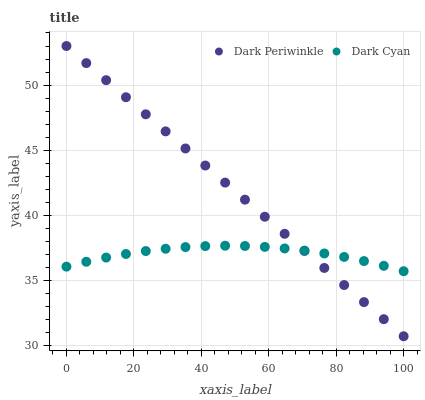Does Dark Cyan have the minimum area under the curve?
Answer yes or no. Yes. Does Dark Periwinkle have the maximum area under the curve?
Answer yes or no. Yes. Does Dark Periwinkle have the minimum area under the curve?
Answer yes or no. No. Is Dark Periwinkle the smoothest?
Answer yes or no. Yes. Is Dark Cyan the roughest?
Answer yes or no. Yes. Is Dark Periwinkle the roughest?
Answer yes or no. No. Does Dark Periwinkle have the lowest value?
Answer yes or no. Yes. Does Dark Periwinkle have the highest value?
Answer yes or no. Yes. Does Dark Periwinkle intersect Dark Cyan?
Answer yes or no. Yes. Is Dark Periwinkle less than Dark Cyan?
Answer yes or no. No. Is Dark Periwinkle greater than Dark Cyan?
Answer yes or no. No. 